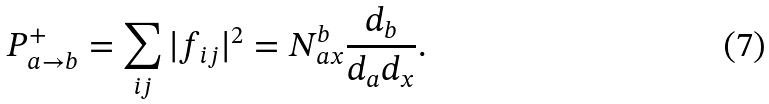<formula> <loc_0><loc_0><loc_500><loc_500>P ^ { + } _ { a \rightarrow b } = \sum _ { i j } | f _ { i j } | ^ { 2 } = N ^ { b } _ { a x } \frac { d _ { b } } { d _ { a } d _ { x } } .</formula> 